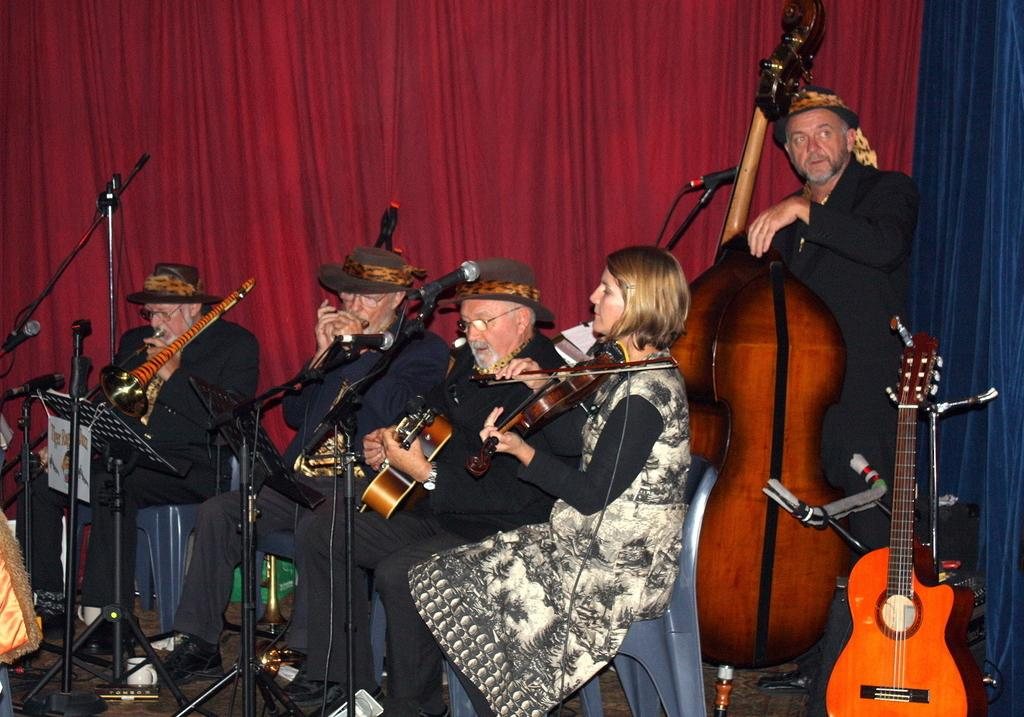What are the people in the image doing? The people in the image are seated and playing musical instruments. Can you describe the man standing in the image? The man standing in the image is playing a violin. What else can be seen in the image besides the people and the man? There is a curtain visible in the image. What type of bat can be seen hanging from the curtain in the image? There is no bat present in the image; only the people, the man, and the curtain are visible. 